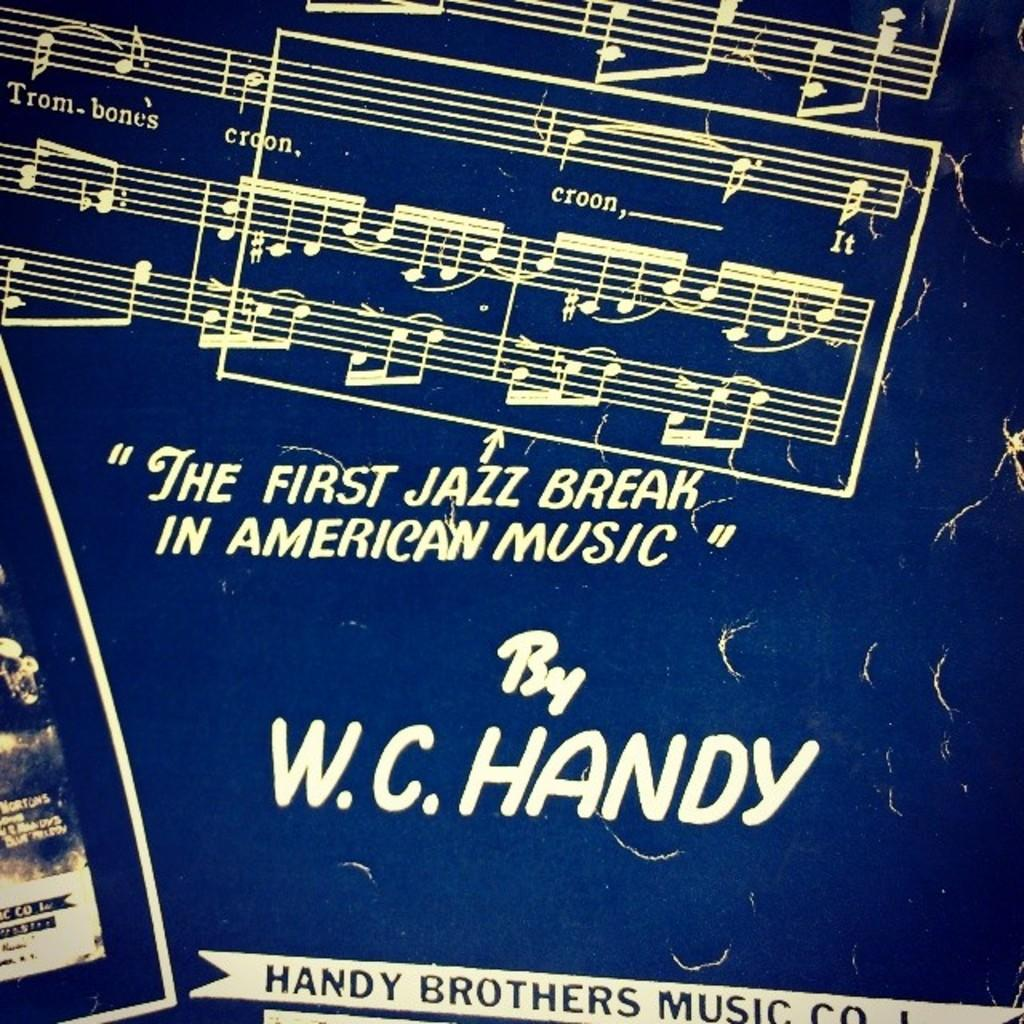What is the color of the poster in the picture? The poster is blue-colored. What is written or displayed on the poster? The poster has edited text on it. What else can be seen on the poster besides the text? The poster contains notes of music. Can you see any leaves on the ground in the image? There is no mention of leaves or a ground in the provided facts, so it cannot be determined if they are present in the image. 